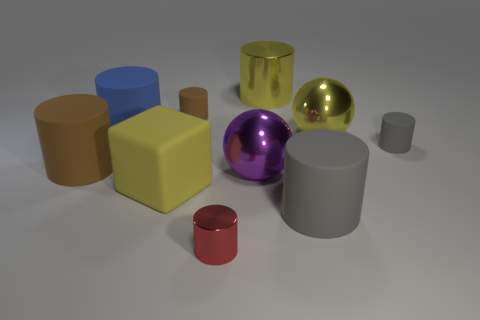Do the big metallic cylinder and the tiny shiny thing have the same color?
Provide a short and direct response. No. The large thing behind the small brown matte object that is to the left of the yellow metallic cylinder is made of what material?
Make the answer very short. Metal. There is a yellow object that is the same shape as the big blue thing; what is it made of?
Your answer should be compact. Metal. There is a small matte thing that is right of the red object that is on the right side of the blue cylinder; are there any small rubber objects to the left of it?
Offer a very short reply. Yes. What number of other objects are there of the same color as the block?
Provide a short and direct response. 2. What number of small cylinders are both to the left of the tiny gray object and behind the big brown rubber object?
Provide a succinct answer. 1. What is the shape of the big purple object?
Offer a very short reply. Sphere. How many other things are made of the same material as the big yellow cylinder?
Give a very brief answer. 3. There is a large rubber thing right of the metallic object behind the brown rubber cylinder that is right of the big yellow cube; what color is it?
Keep it short and to the point. Gray. What is the material of the brown cylinder that is the same size as the blue matte thing?
Provide a short and direct response. Rubber. 